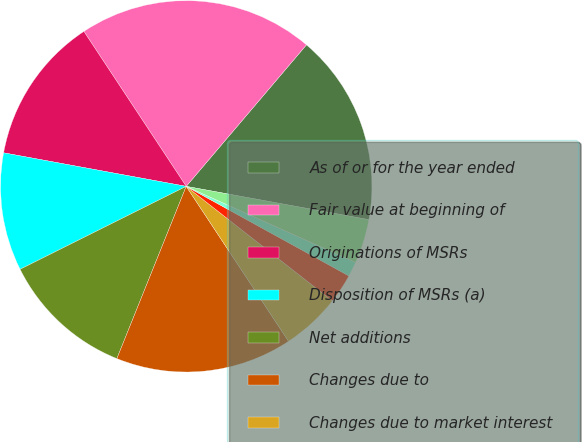<chart> <loc_0><loc_0><loc_500><loc_500><pie_chart><fcel>As of or for the year ended<fcel>Fair value at beginning of<fcel>Originations of MSRs<fcel>Disposition of MSRs (a)<fcel>Net additions<fcel>Changes due to<fcel>Changes due to market interest<fcel>Projected cash flows (eg cost<fcel>Discount rates<fcel>Prepayment model changes and<nl><fcel>16.66%<fcel>20.5%<fcel>12.82%<fcel>10.26%<fcel>11.54%<fcel>15.38%<fcel>5.13%<fcel>2.57%<fcel>1.29%<fcel>3.85%<nl></chart> 